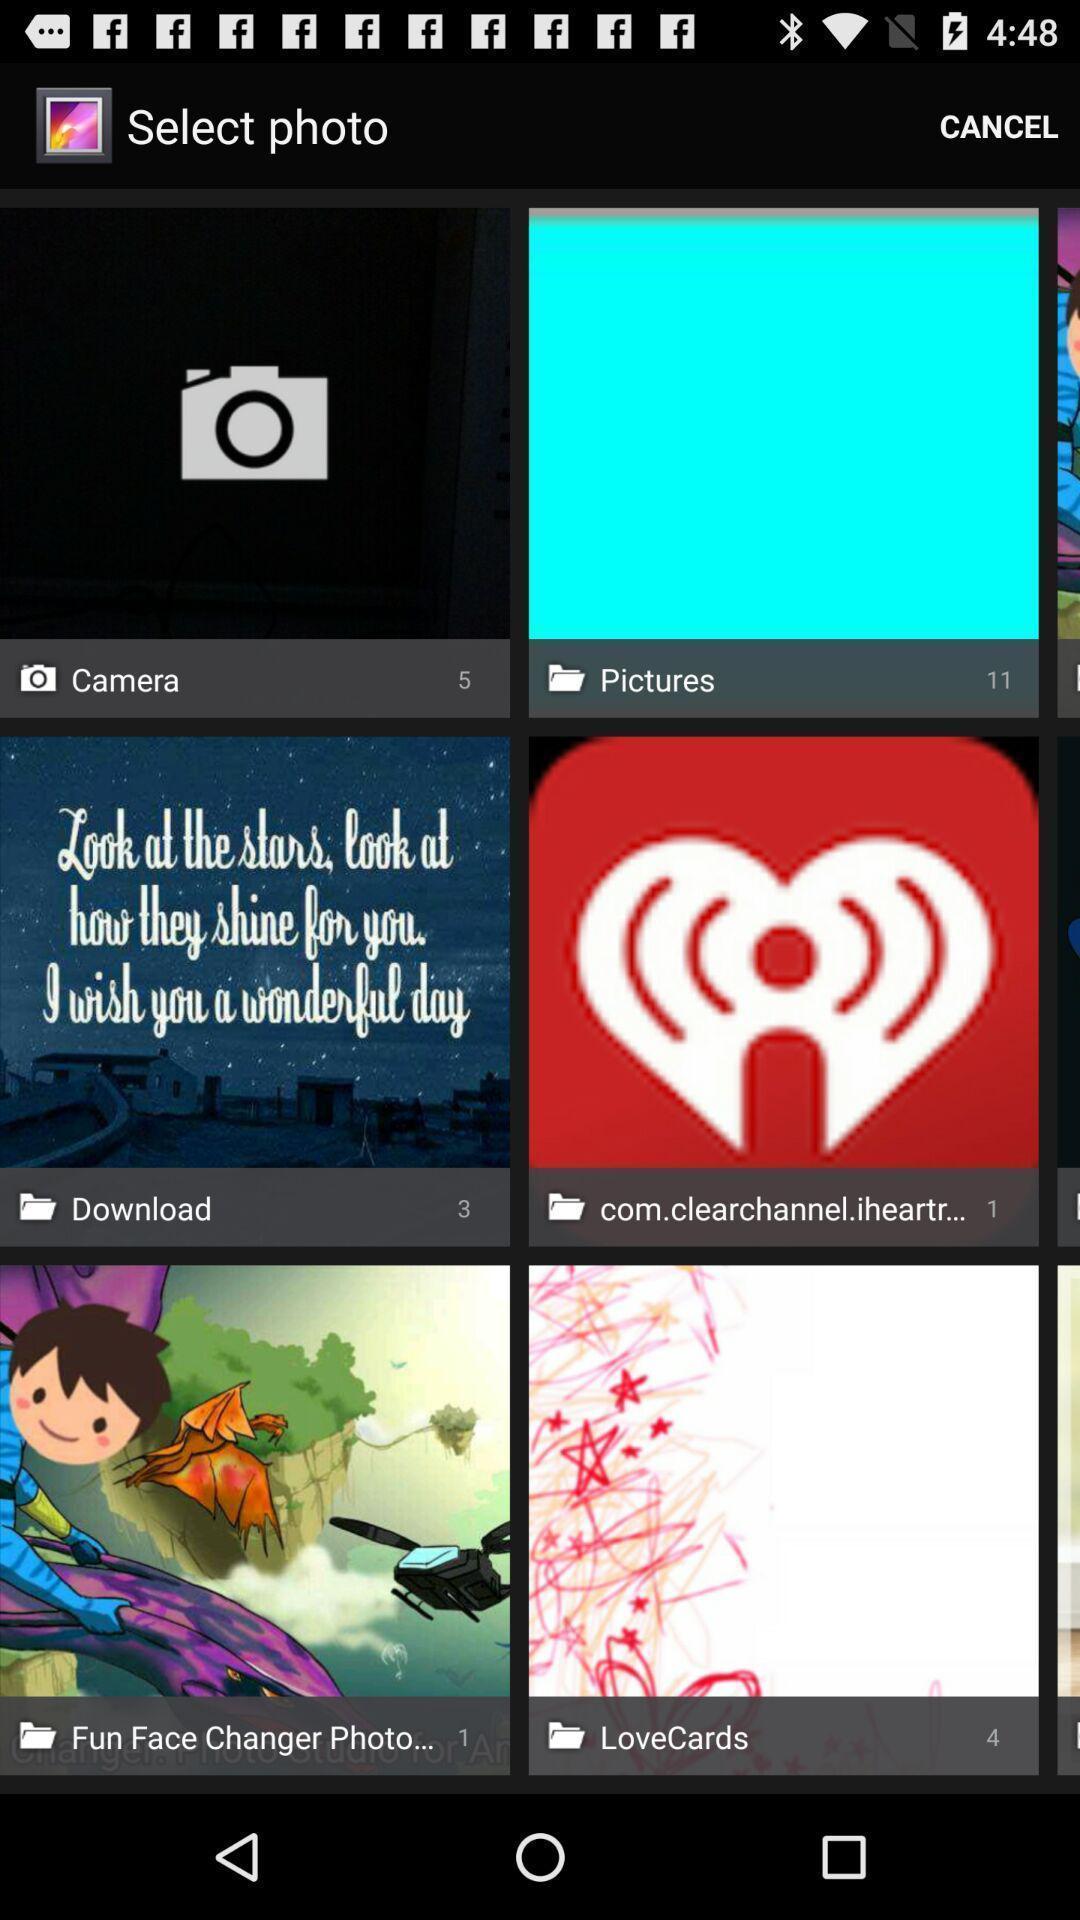Give me a narrative description of this picture. Screen shows to select a photo from gallery. 